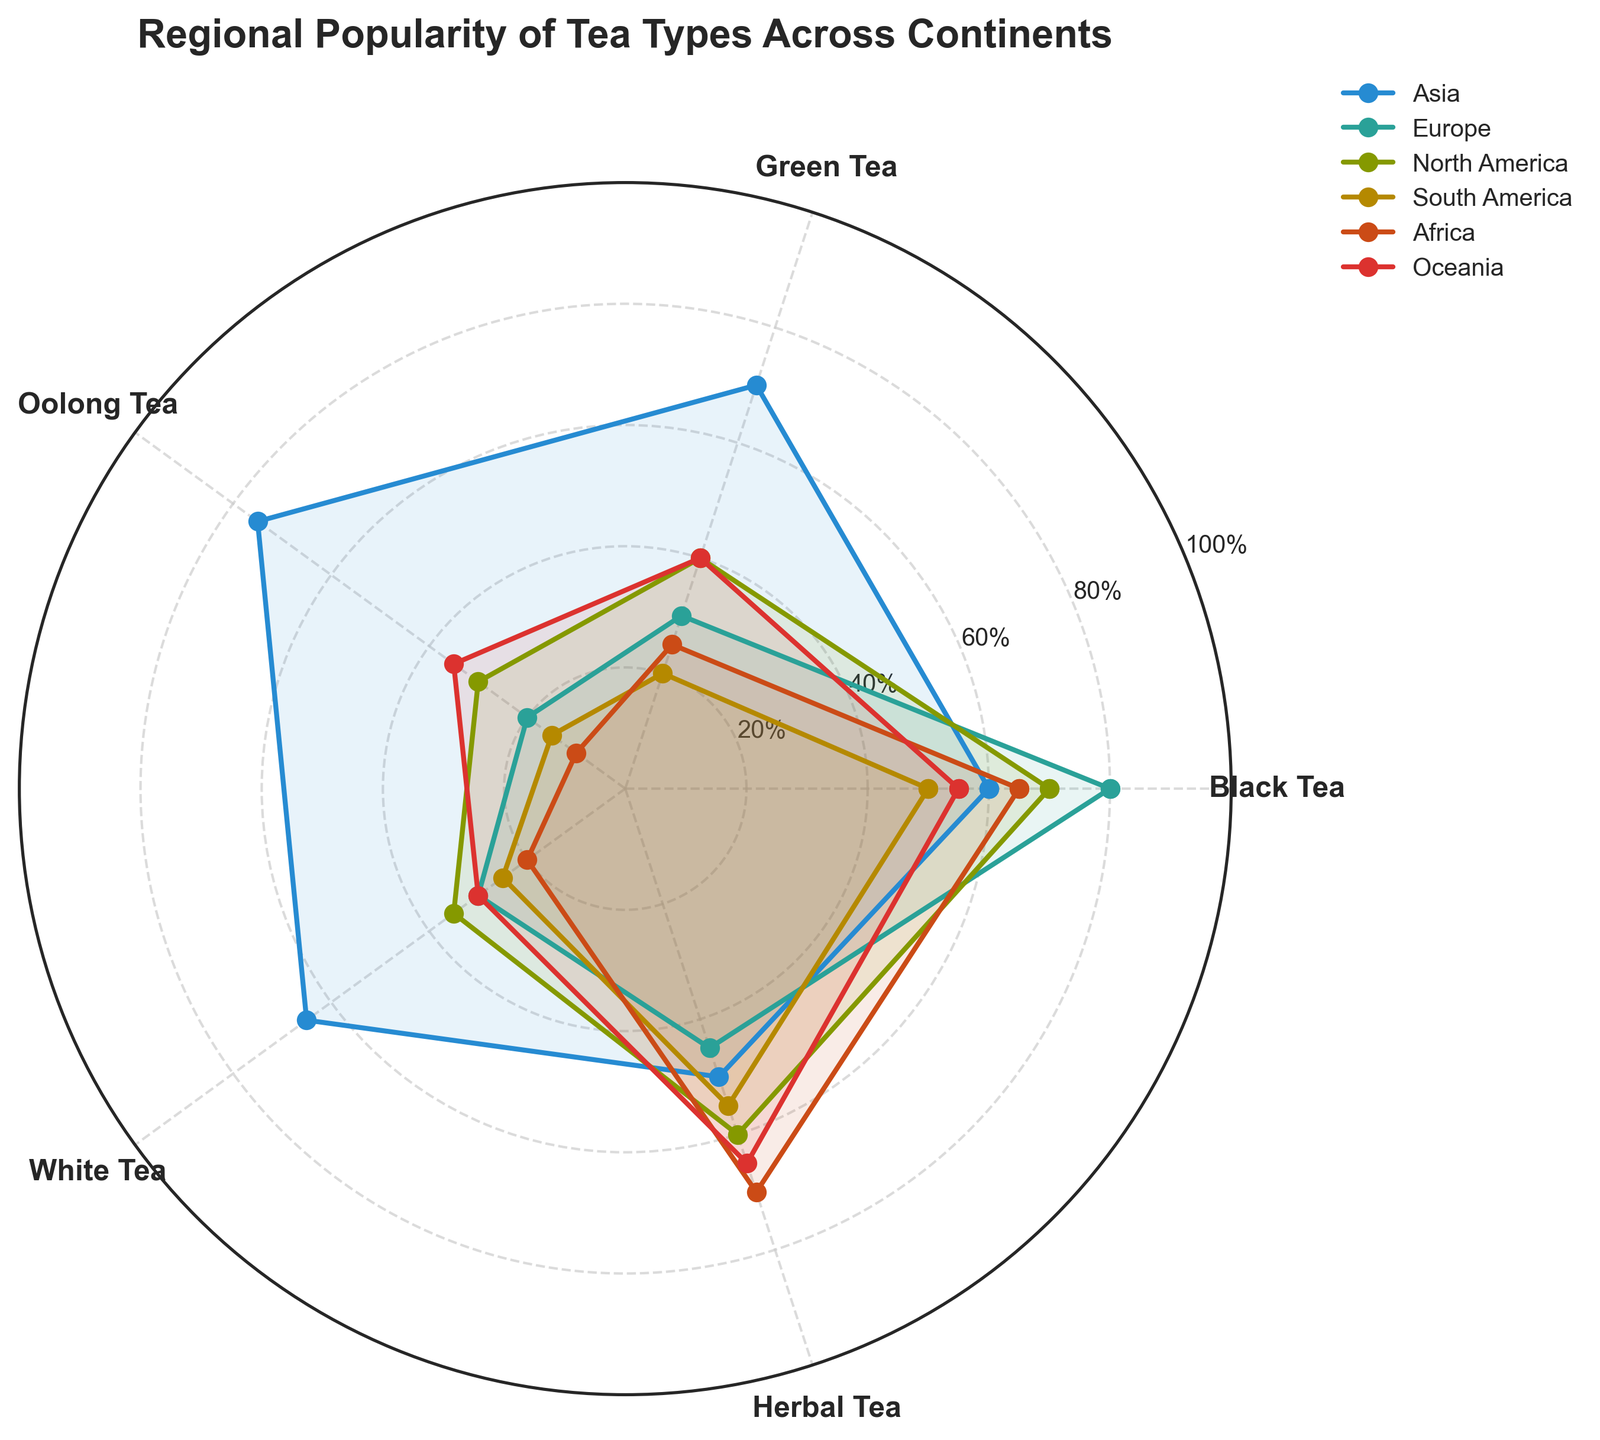what is the title of the figure? The title of the figure is shown at the top and provides a summary of what the chart represents. By looking at it, we can understand that the figure is focused on the popularity of different tea types across various regions.
Answer: Regional Popularity of Tea Types Across Continents Which continent has the highest popularity for Black Tea? To determine the highest popularity, observe the peaks of the series for each continent and compare them for the Black Tea category. The highest peak corresponds to the highest percentage.
Answer: Europe What is the approximate average popularity of Green Tea in Asia and Africa? First, find the Green Tea values for Asia and Africa, which are 70 and 25, respectively. Then, calculate the average: (70+25)/2 = 47.5
Answer: 47.5 How do the popularity percentages of Herbal Tea compare between Africa and Europe? Look at the Herbal Tea points for both continents. Africa has a value of 70, and Europe has 45. By comparing these values, we see that Africa's popularity for Herbal Tea is higher.
Answer: Africa's Herbal Tea popularity is higher than Europe's Which continent has the least variation in popularity percentages across all tea types? To find the continent with the least variation, observe the range of values (difference between the highest and lowest points) for each continent. Oceania's values range from 30 to 65, indicating smaller variation compared to other continents.
Answer: Oceania In which continent is Oolong Tea more popular than Black Tea? Examine the points for Oolong Tea and Black Tea for each continent. In Asia, Oolong Tea (75) is more popular than Black Tea (60).
Answer: Asia Is there any continent where White Tea is more popular than Herbal Tea? Check the values for White Tea and Herbal Tea for each continent. There is no continent where White Tea's popularity exceeds that of Herbal Tea, as Herbal Tea always has higher values.
Answer: No What is the difference in popularity of Black Tea between Europe and South America? Identify the Black Tea values for Europe and South America, which are 80 and 50, respectively. Calculate the difference: 80 - 50 = 30
Answer: 30 Which tea type has the most consistent popularity across all continents? Identify the tea type with the smallest range or the least fluctuation in values across continents. By looking at all tea types, Black Tea varies less extremely between 50 and 80 across continents.
Answer: Black Tea 